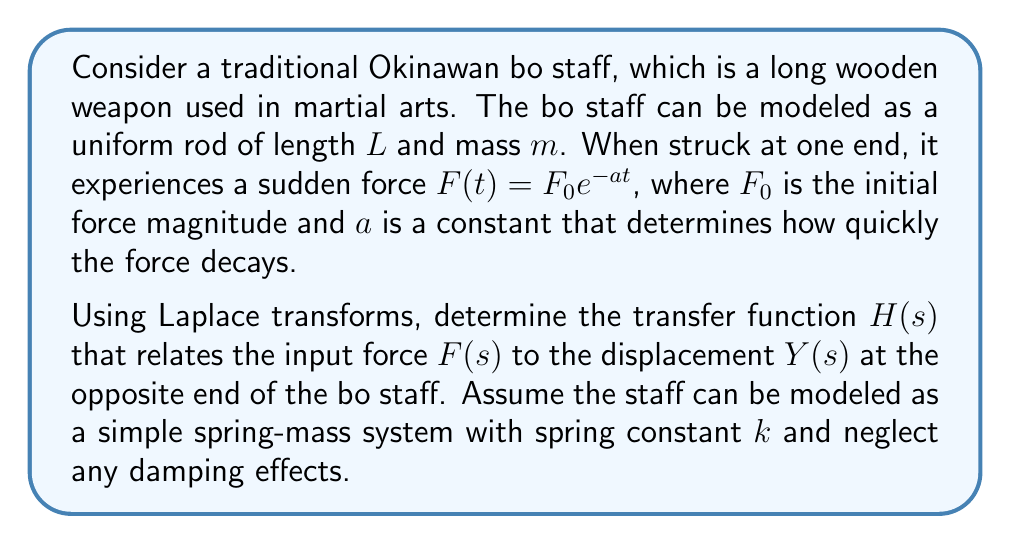Solve this math problem. Let's approach this problem step-by-step:

1) First, we need to set up the differential equation that describes the motion of the bo staff. The equation of motion for a spring-mass system is:

   $$m\frac{d^2y}{dt^2} + ky = F(t)$$

2) We're given that $F(t) = F_0 e^{-at}$. Let's take the Laplace transform of both sides of the equation:

   $$\mathcal{L}\{m\frac{d^2y}{dt^2} + ky\} = \mathcal{L}\{F_0 e^{-at}\}$$

3) Using the properties of Laplace transforms:

   $$m(s^2Y(s) - sy(0) - y'(0)) + kY(s) = F_0 \cdot \frac{1}{s+a}$$

   Assuming initial conditions $y(0) = 0$ and $y'(0) = 0$:

   $$ms^2Y(s) + kY(s) = \frac{F_0}{s+a}$$

4) Factoring out $Y(s)$:

   $$Y(s)(ms^2 + k) = \frac{F_0}{s+a}$$

5) Solving for $Y(s)$:

   $$Y(s) = \frac{F_0}{(ms^2 + k)(s+a)}$$

6) The transfer function $H(s)$ is defined as the ratio of output to input in the s-domain:

   $$H(s) = \frac{Y(s)}{F(s)} = \frac{Y(s)}{F_0/(s+a)} = \frac{1}{(ms^2 + k)(s+a)} \cdot (s+a)$$

7) Simplifying:

   $$H(s) = \frac{1}{ms^2 + k}$$

This is the transfer function that relates the input force to the displacement at the opposite end of the bo staff.
Answer: $$H(s) = \frac{1}{ms^2 + k}$$ 